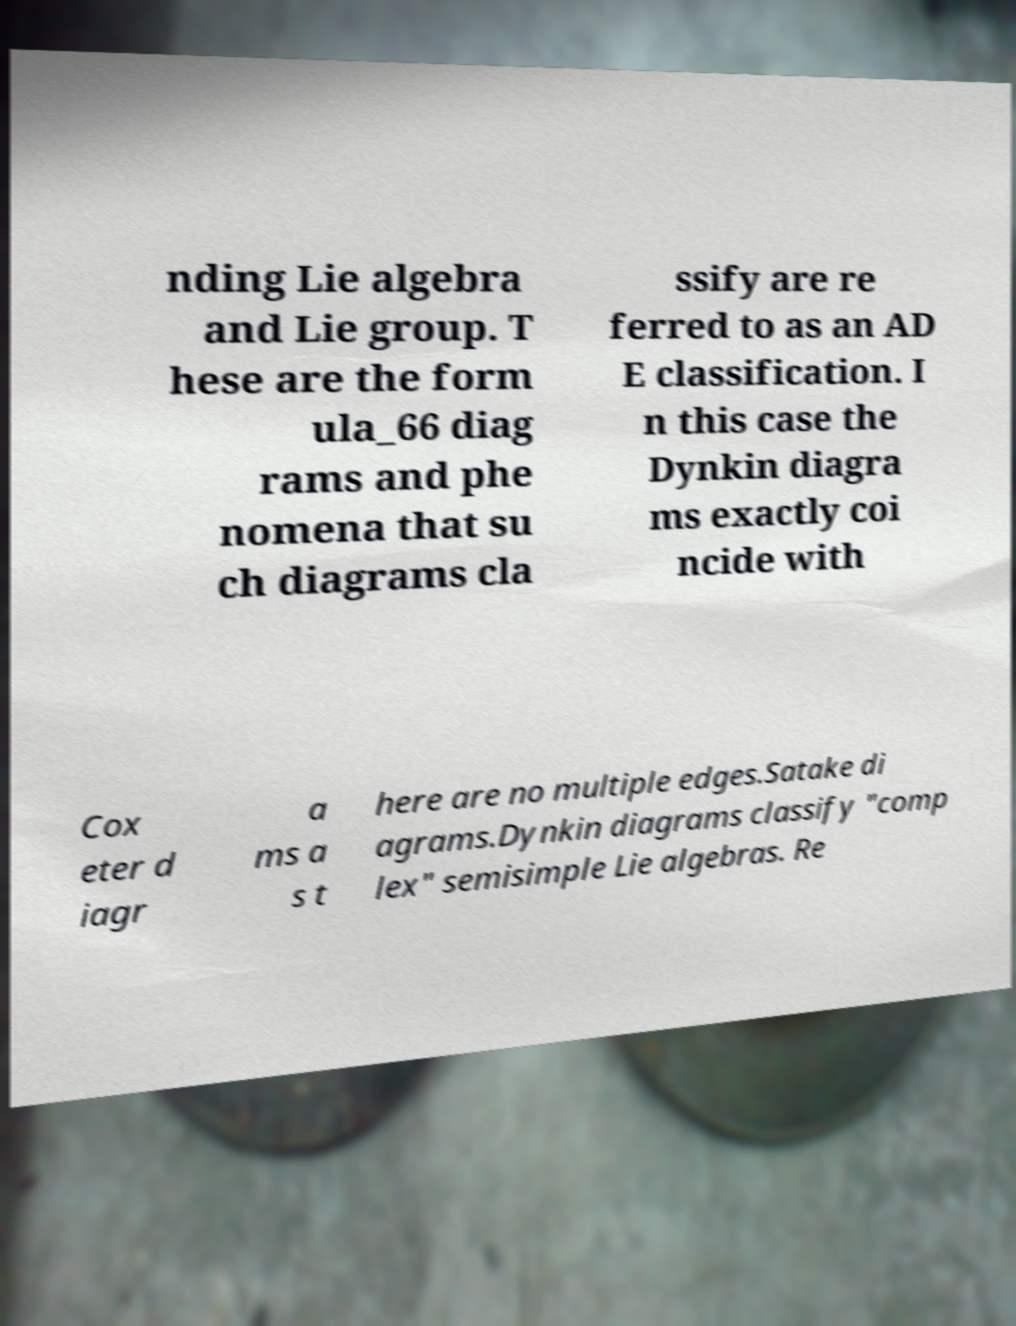Could you extract and type out the text from this image? nding Lie algebra and Lie group. T hese are the form ula_66 diag rams and phe nomena that su ch diagrams cla ssify are re ferred to as an AD E classification. I n this case the Dynkin diagra ms exactly coi ncide with Cox eter d iagr a ms a s t here are no multiple edges.Satake di agrams.Dynkin diagrams classify "comp lex" semisimple Lie algebras. Re 